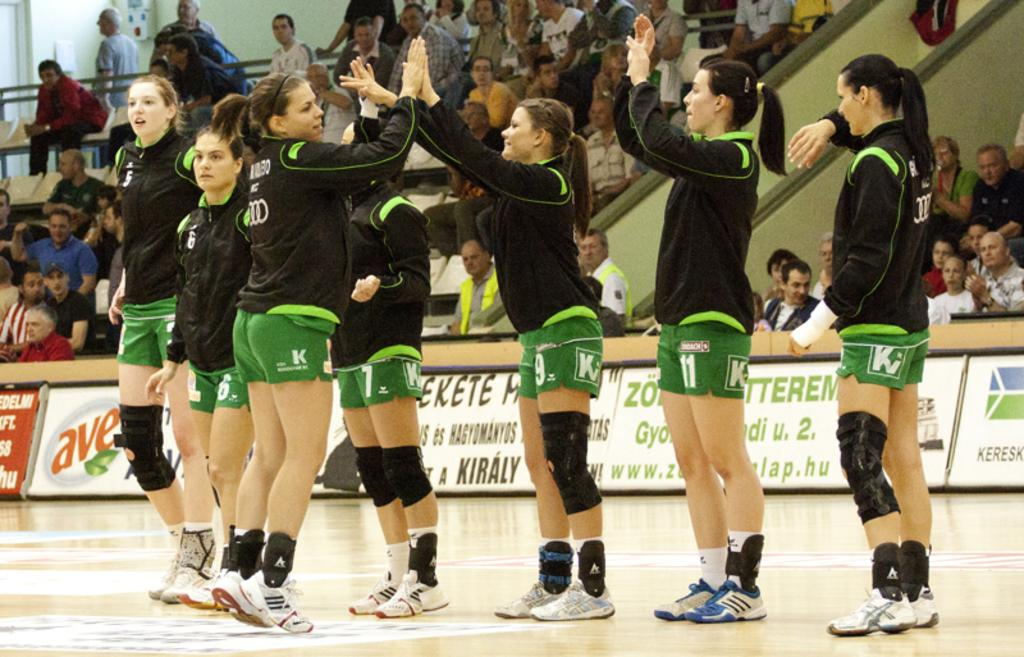Provide a one-sentence caption for the provided image. seven women in outfits marked with a "KV" logo. 